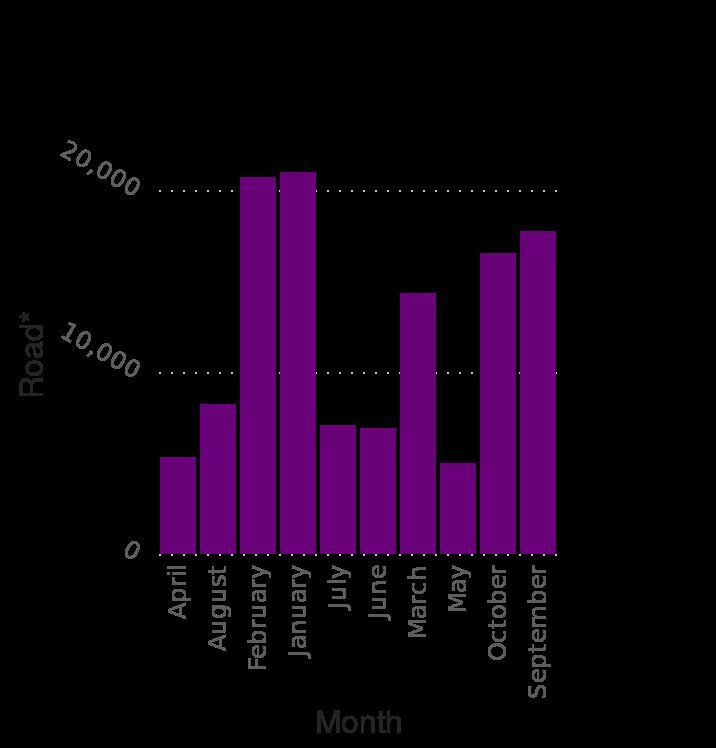<image>
What is the range of the y-axis in the bar graph? The range of the y-axis in the bar graph is from 0 to 20,000. Which month is represented on the left end of the x-axis? April is represented on the left end of the x-axis. 